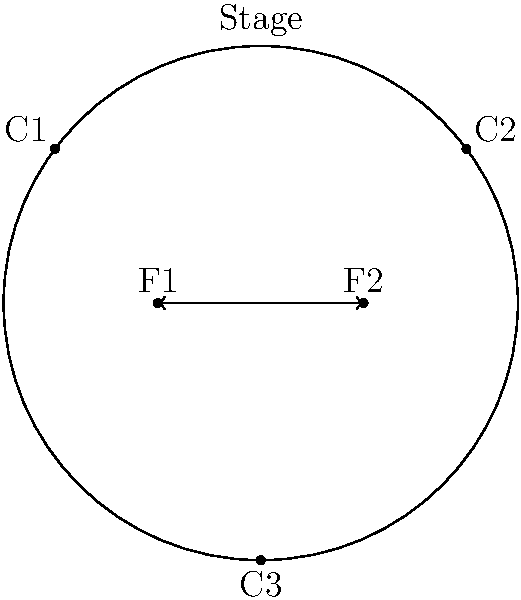In the given top-down diagram of a stage for an MMA fight scene, two fighters (F1 and F2) are positioned on opposite sides of a circular stage with three camera positions (C1, C2, and C3) surrounding them. If the director wants to capture a sequence where the fighters exchange positions while maintaining a clear line of sight for all cameras, what is the optimal path for both fighters to move simultaneously? To determine the optimal path for the fighters to exchange positions while maintaining clear camera lines, we need to consider the following steps:

1. Analyze the current positions:
   - F1 is at (-2,0) and F2 is at (2,0)
   - Cameras are positioned at C1 (-4,3), C2 (4,3), and C3 (0,-5)

2. Consider the constraints:
   - The fighters need to exchange positions
   - All cameras should have a clear line of sight throughout the movement
   - The movement should be simultaneous

3. Evaluate possible paths:
   - Straight line: This would cause the fighters to collide at the center
   - Circular path: This could work, but may block camera views depending on the direction

4. Determine the optimal solution:
   - The best path is for both fighters to move in semicircles
   - F1 should move clockwise, and F2 should move counterclockwise
   - This creates a rotational symmetry in their movement

5. Verify camera angles:
   - C1 and C2 will have clear views of both fighters throughout the movement
   - C3 will have a partially obstructed view when the fighters cross, but this is unavoidable and minimal

6. Consider choreography implications:
   - This movement allows for potential dramatic moments as the fighters pass each other
   - It provides opportunities for close-up shots from C1 and C2 during the crossing

By following semicircular paths in opposite directions, the fighters can exchange positions efficiently while maximizing camera coverage and creating visually interesting choreography for the scene.
Answer: Semicircular paths: F1 clockwise, F2 counterclockwise 